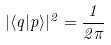<formula> <loc_0><loc_0><loc_500><loc_500>| \langle q | p \rangle | ^ { 2 } = \frac { 1 } { 2 \pi }</formula> 